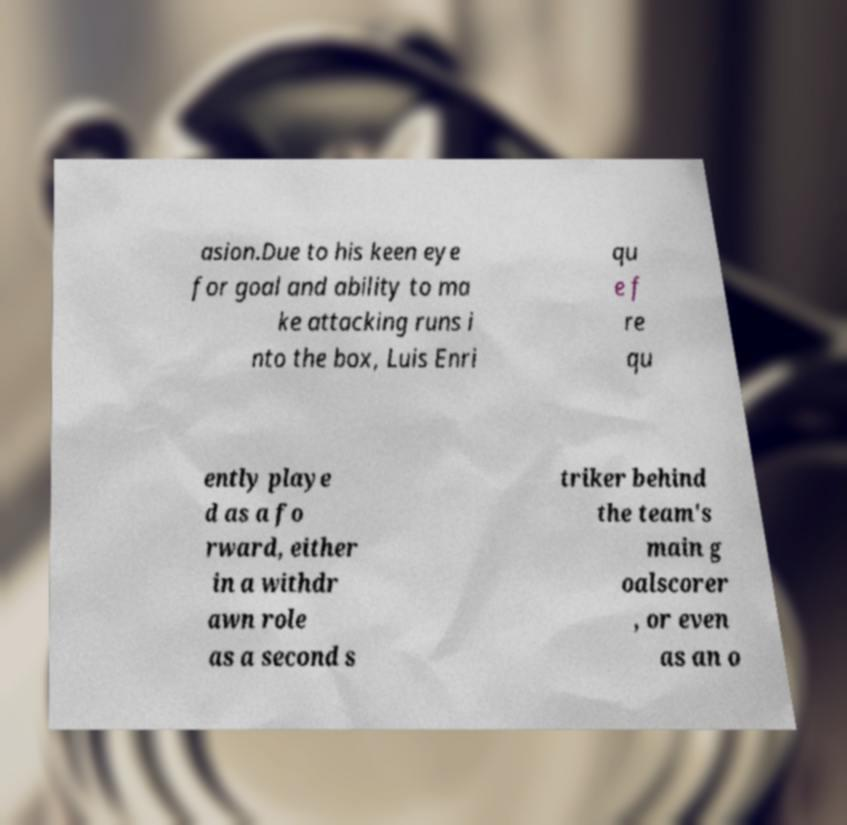For documentation purposes, I need the text within this image transcribed. Could you provide that? asion.Due to his keen eye for goal and ability to ma ke attacking runs i nto the box, Luis Enri qu e f re qu ently playe d as a fo rward, either in a withdr awn role as a second s triker behind the team's main g oalscorer , or even as an o 